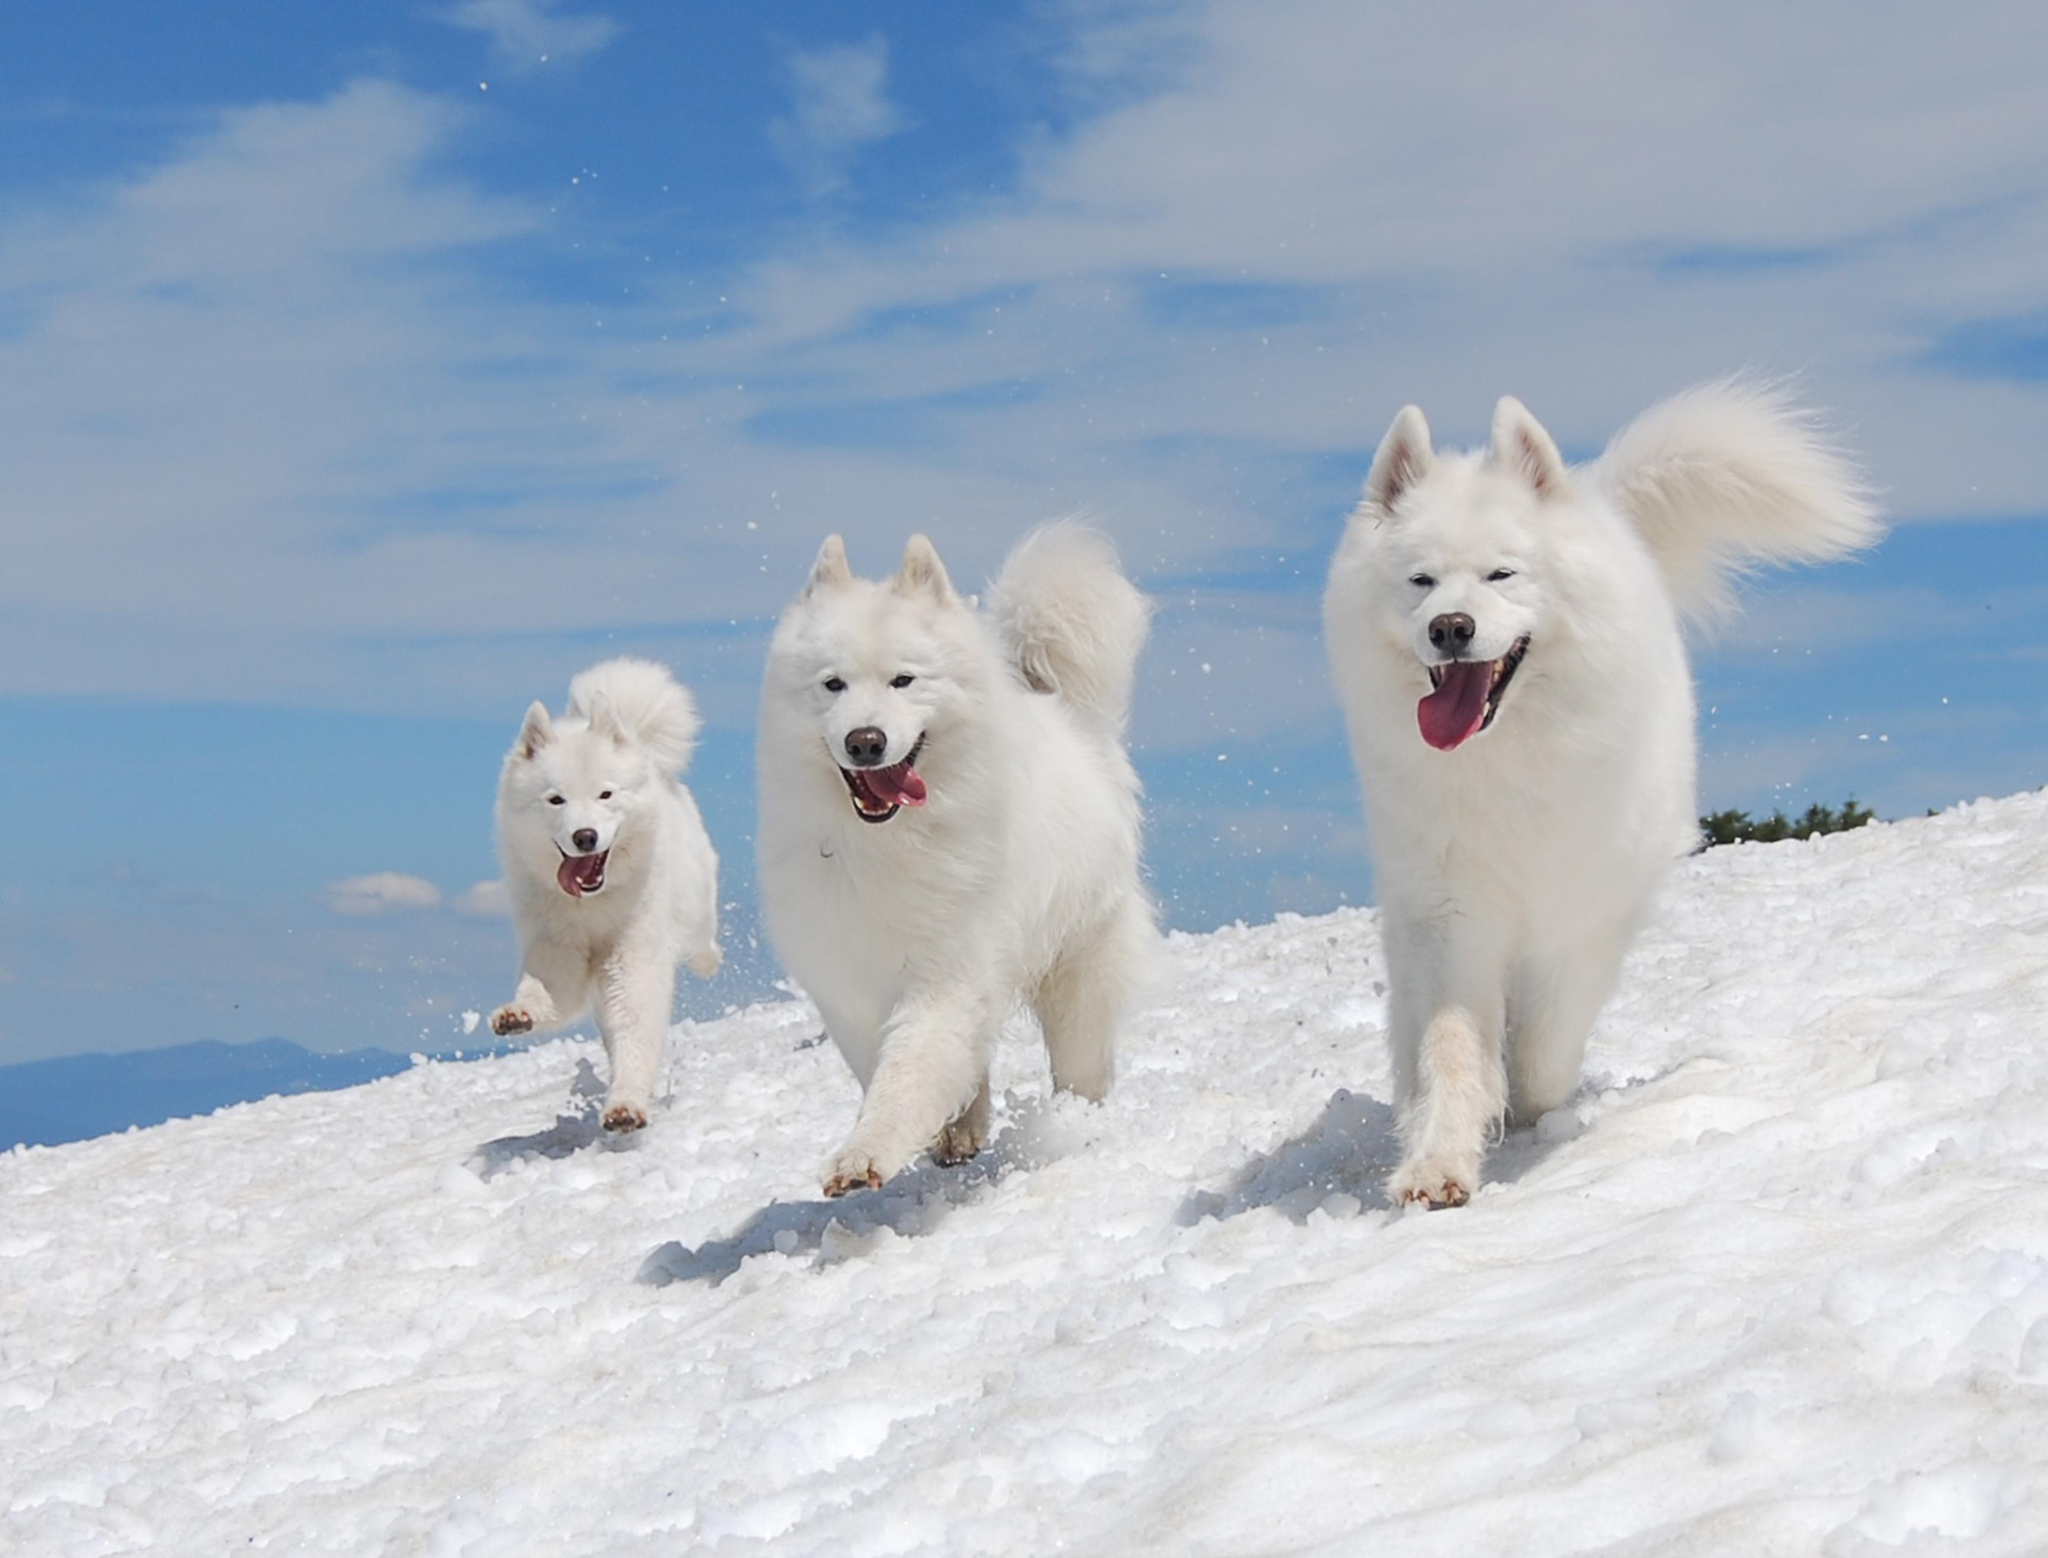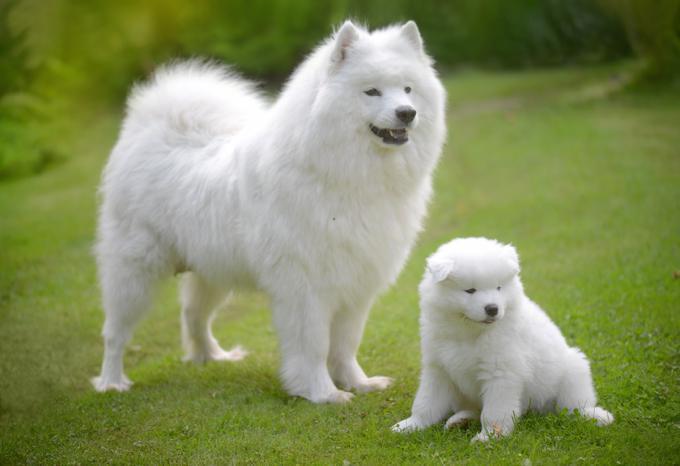The first image is the image on the left, the second image is the image on the right. Given the left and right images, does the statement "At least one of the images features a puppy without an adult." hold true? Answer yes or no. No. The first image is the image on the left, the second image is the image on the right. Given the left and right images, does the statement "Atleast one picture of a single dog posing on grass" hold true? Answer yes or no. No. 